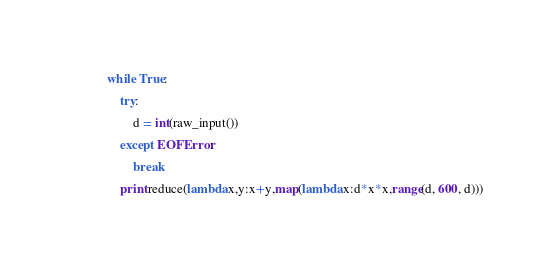Convert code to text. <code><loc_0><loc_0><loc_500><loc_500><_Python_>while True:
    try:
        d = int(raw_input())
    except EOFError:
        break
    print reduce(lambda x,y:x+y,map(lambda x:d*x*x,range(d, 600, d)))</code> 